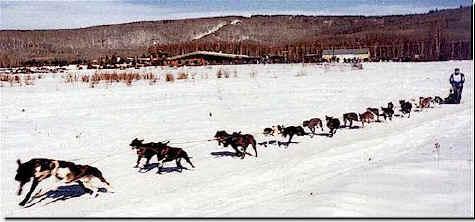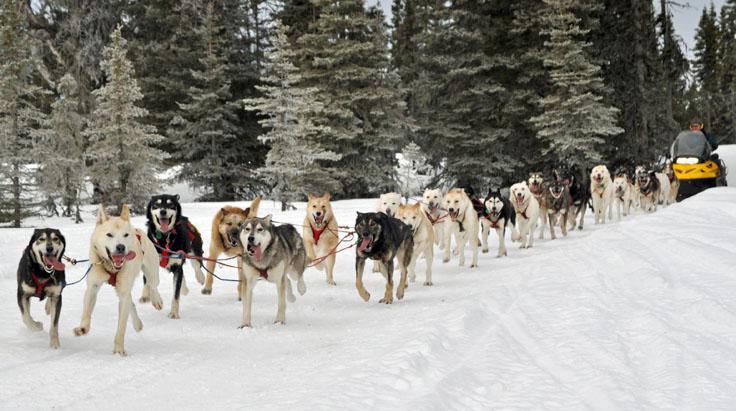The first image is the image on the left, the second image is the image on the right. For the images displayed, is the sentence "Only one of the images shows a team of dogs pulling a sled." factually correct? Answer yes or no. No. The first image is the image on the left, the second image is the image on the right. Assess this claim about the two images: "One image shows a sled dog team moving down a path in the snow, and the other image shows sled dogs that are not hitched or working.". Correct or not? Answer yes or no. No. 